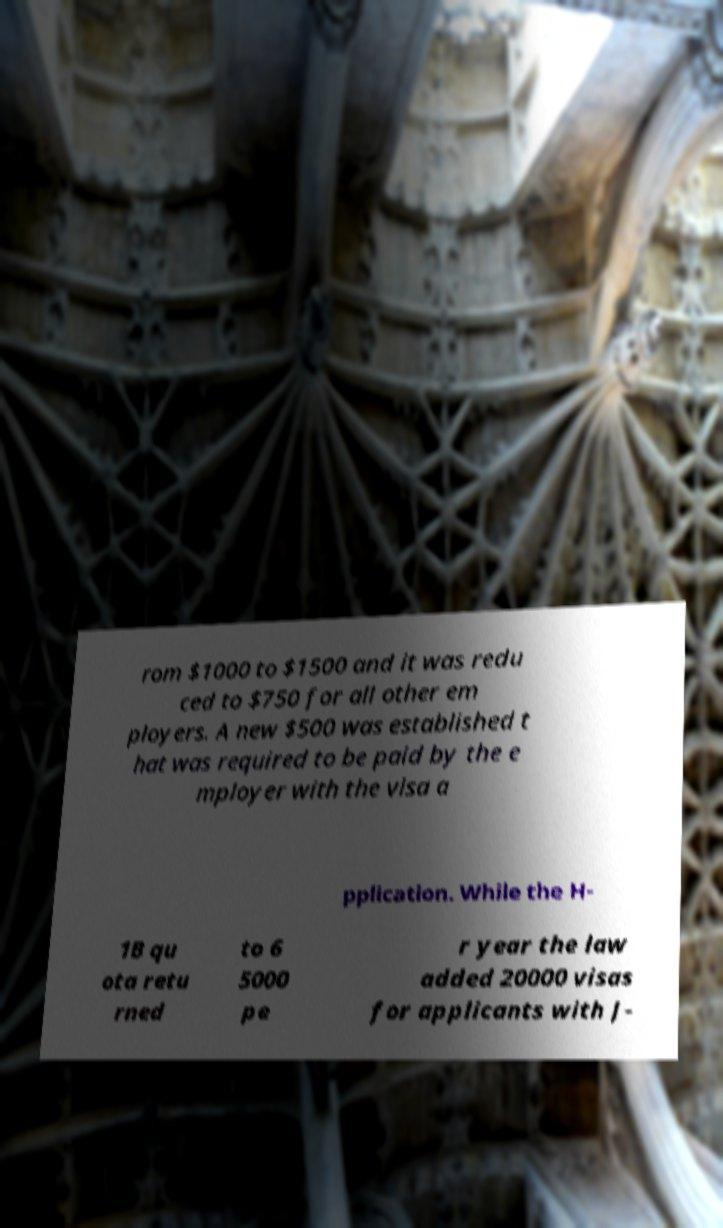Could you extract and type out the text from this image? rom $1000 to $1500 and it was redu ced to $750 for all other em ployers. A new $500 was established t hat was required to be paid by the e mployer with the visa a pplication. While the H- 1B qu ota retu rned to 6 5000 pe r year the law added 20000 visas for applicants with J- 